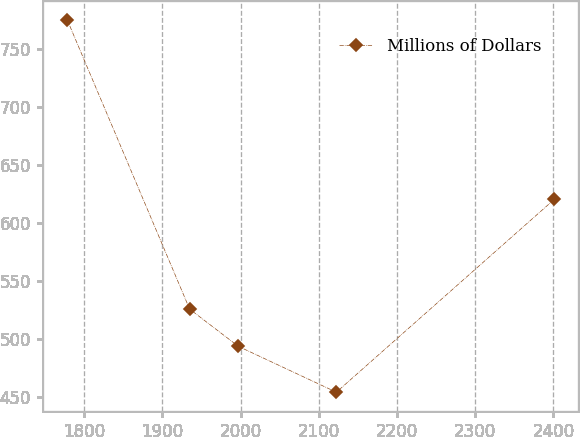<chart> <loc_0><loc_0><loc_500><loc_500><line_chart><ecel><fcel>Millions of Dollars<nl><fcel>1777.99<fcel>775.18<nl><fcel>1934.74<fcel>525.83<nl><fcel>1997.05<fcel>493.74<nl><fcel>2122.46<fcel>454.25<nl><fcel>2401.05<fcel>620.24<nl></chart> 